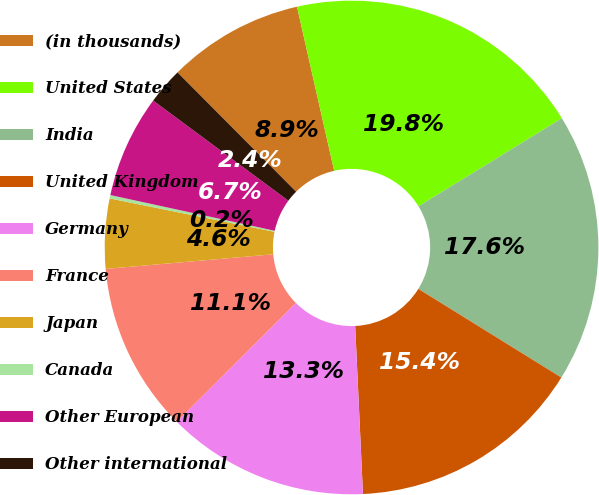Convert chart. <chart><loc_0><loc_0><loc_500><loc_500><pie_chart><fcel>(in thousands)<fcel>United States<fcel>India<fcel>United Kingdom<fcel>Germany<fcel>France<fcel>Japan<fcel>Canada<fcel>Other European<fcel>Other international<nl><fcel>8.91%<fcel>19.78%<fcel>17.6%<fcel>15.43%<fcel>13.26%<fcel>11.09%<fcel>4.57%<fcel>0.22%<fcel>6.74%<fcel>2.4%<nl></chart> 